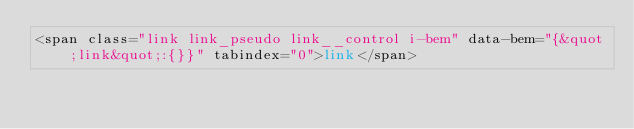<code> <loc_0><loc_0><loc_500><loc_500><_PHP_><span class="link link_pseudo link__control i-bem" data-bem="{&quot;link&quot;:{}}" tabindex="0">link</span></code> 